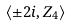Convert formula to latex. <formula><loc_0><loc_0><loc_500><loc_500>\langle \pm 2 i , Z _ { 4 } \rangle</formula> 